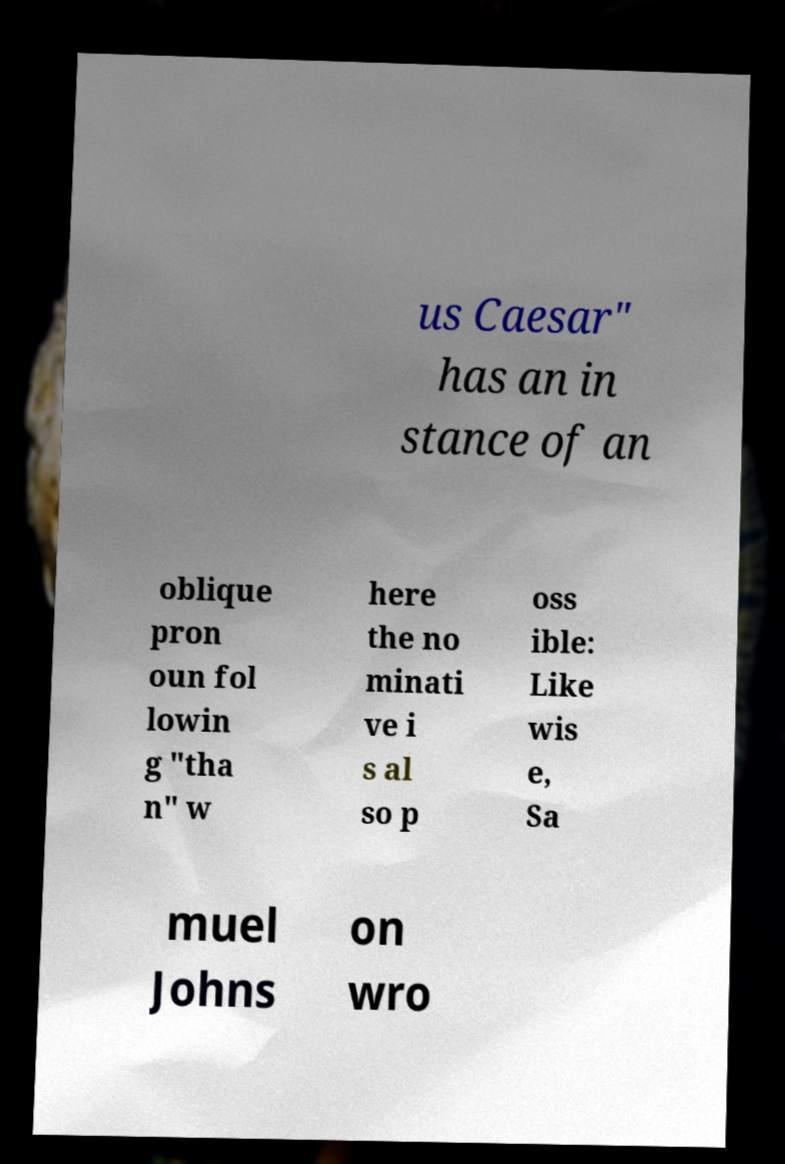Could you assist in decoding the text presented in this image and type it out clearly? us Caesar" has an in stance of an oblique pron oun fol lowin g "tha n" w here the no minati ve i s al so p oss ible: Like wis e, Sa muel Johns on wro 